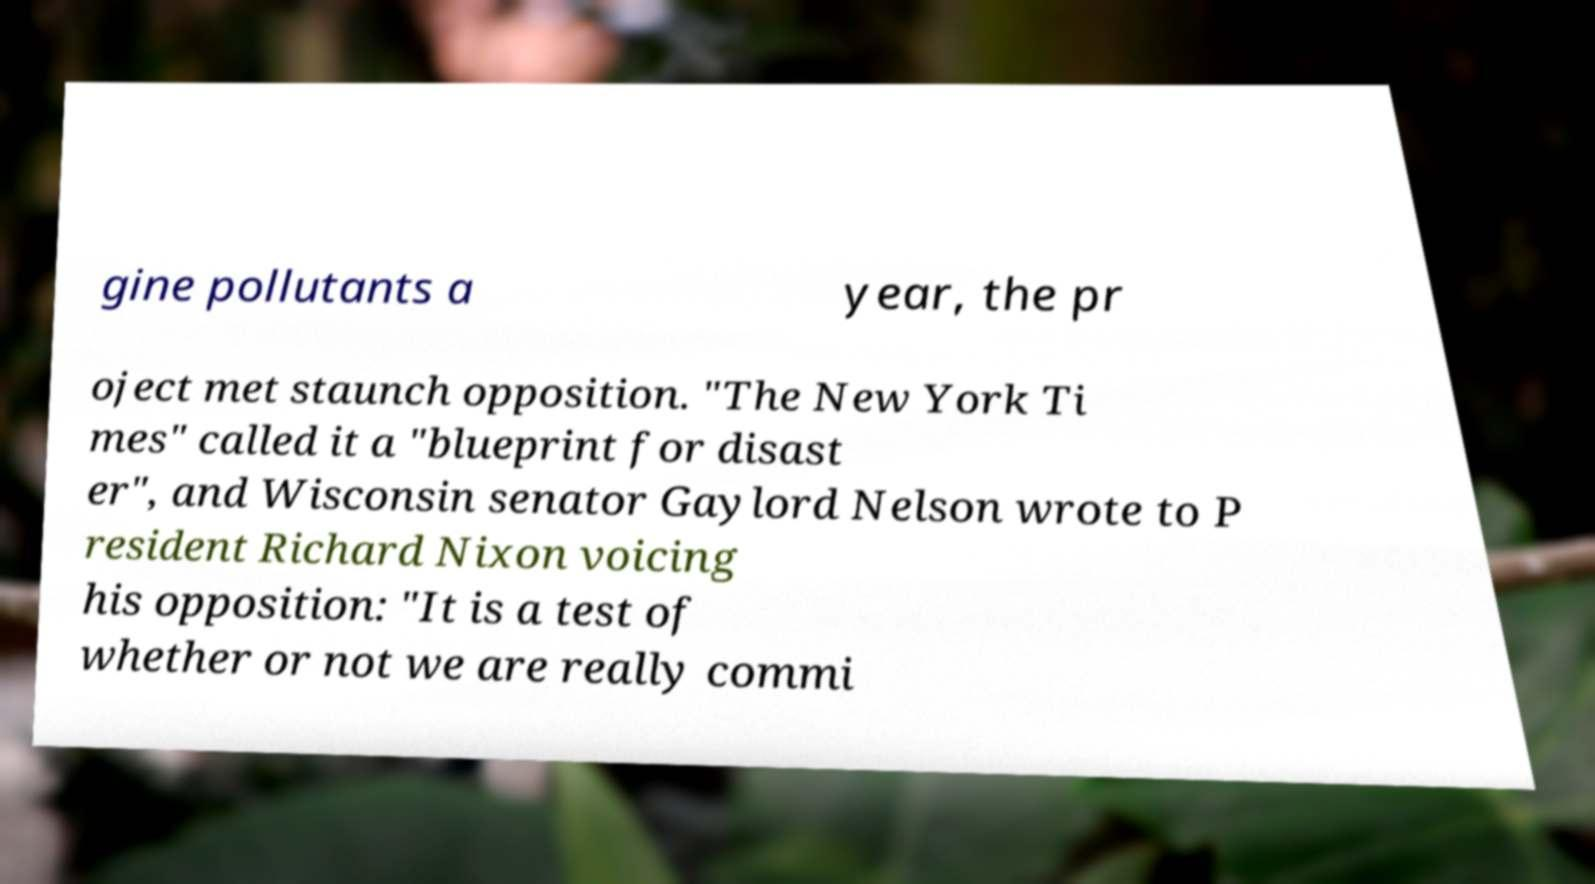Please read and relay the text visible in this image. What does it say? gine pollutants a year, the pr oject met staunch opposition. "The New York Ti mes" called it a "blueprint for disast er", and Wisconsin senator Gaylord Nelson wrote to P resident Richard Nixon voicing his opposition: "It is a test of whether or not we are really commi 